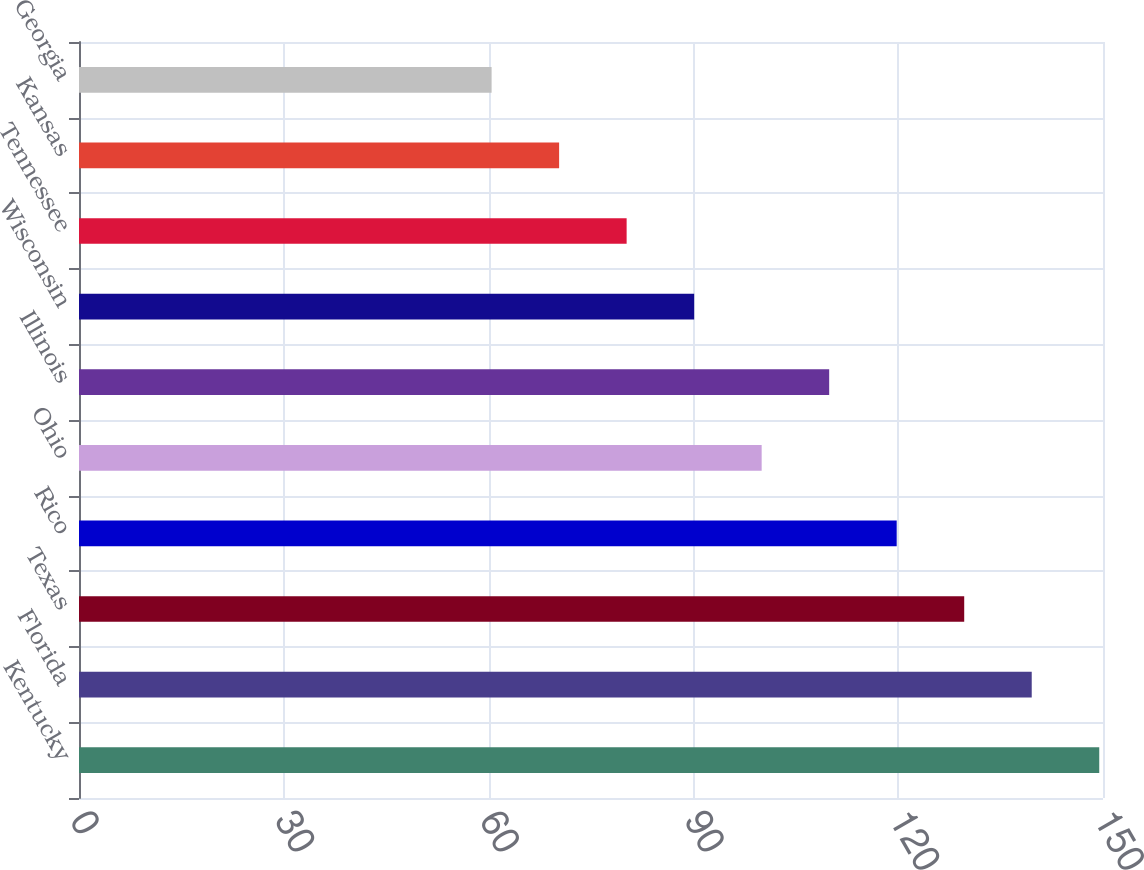Convert chart. <chart><loc_0><loc_0><loc_500><loc_500><bar_chart><fcel>Kentucky<fcel>Florida<fcel>Texas<fcel>Rico<fcel>Ohio<fcel>Illinois<fcel>Wisconsin<fcel>Tennessee<fcel>Kansas<fcel>Georgia<nl><fcel>149.45<fcel>139.56<fcel>129.67<fcel>119.78<fcel>100<fcel>109.89<fcel>90.11<fcel>80.22<fcel>70.33<fcel>60.44<nl></chart> 